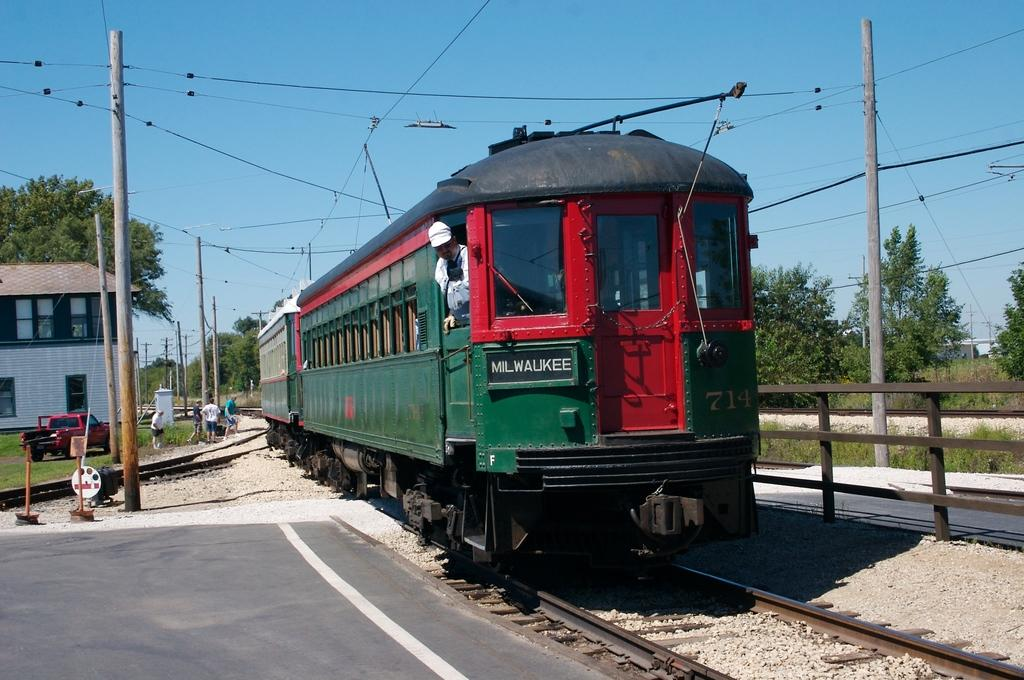What is the main subject of the image? The main subject of the image is a train on the railway track. What other objects or structures can be seen in the image? There are poles, wires, fencing, a house, windows, a vehicle, people, and trees in the image. What is the color of the sky in the image? The sky is blue in the image. What is the weight of the train in the image? The weight of the train cannot be determined from the image alone. --- Facts: 1. There is a person holding a book. 2. The person is sitting on a chair. 3. There is a table in the image. 4. There is a lamp on the table. 5. The background of the image is a wall. Absurd Topics: ocean, parrot, bicycle Conversation: What is the person in the image holding? The person is holding a book in the image. What is the person sitting on? The person is sitting on a chair in the image. What is present on the table in the image? There is a lamp on the table in the image. What can be seen in the background of the image? The background of the image is a wall. Reasoning: Let's think step by step in order to produce the conversation. We start by identifying the main subject of the image, which is the person holding a book. Then, we describe the person's position and the objects around them, such as the chair and the table with a lamp. Finally, we mention the background of the image, which is a wall. Absurd Question/Answer: Can you see any ocean or parrot in the image? No, there is no ocean or parrot present in the image. 